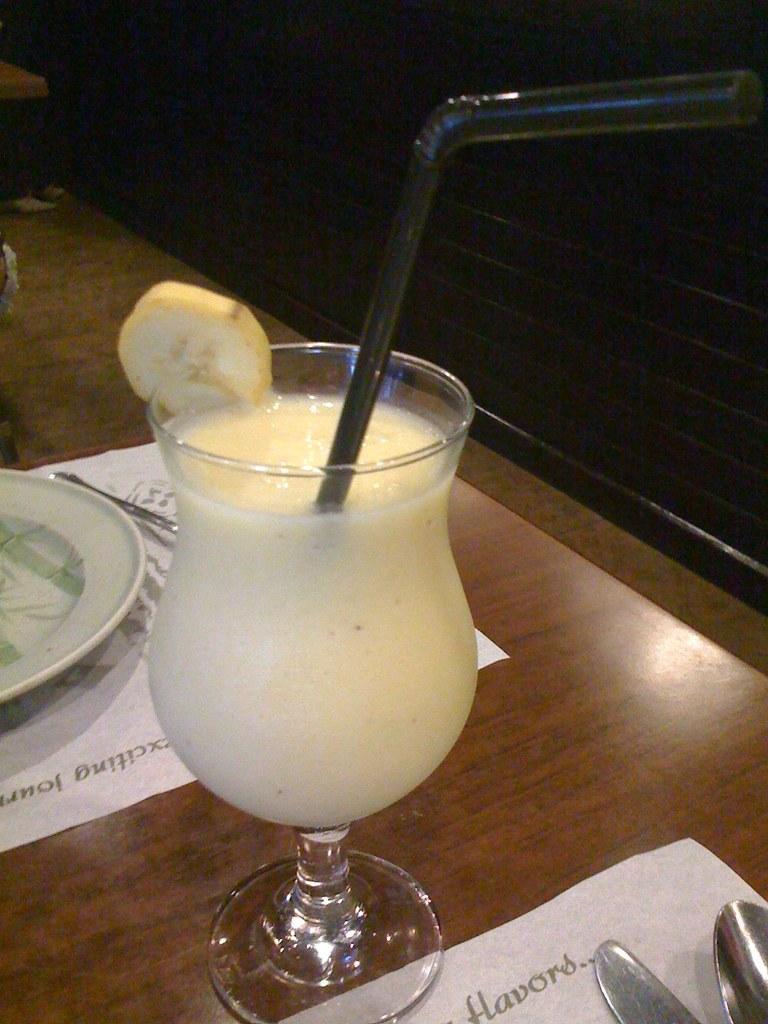Please provide a concise description of this image. At the bottom of the image there is a table and we can see a glass containing drink, plate, knife, spoon and a paper placed on the table. 